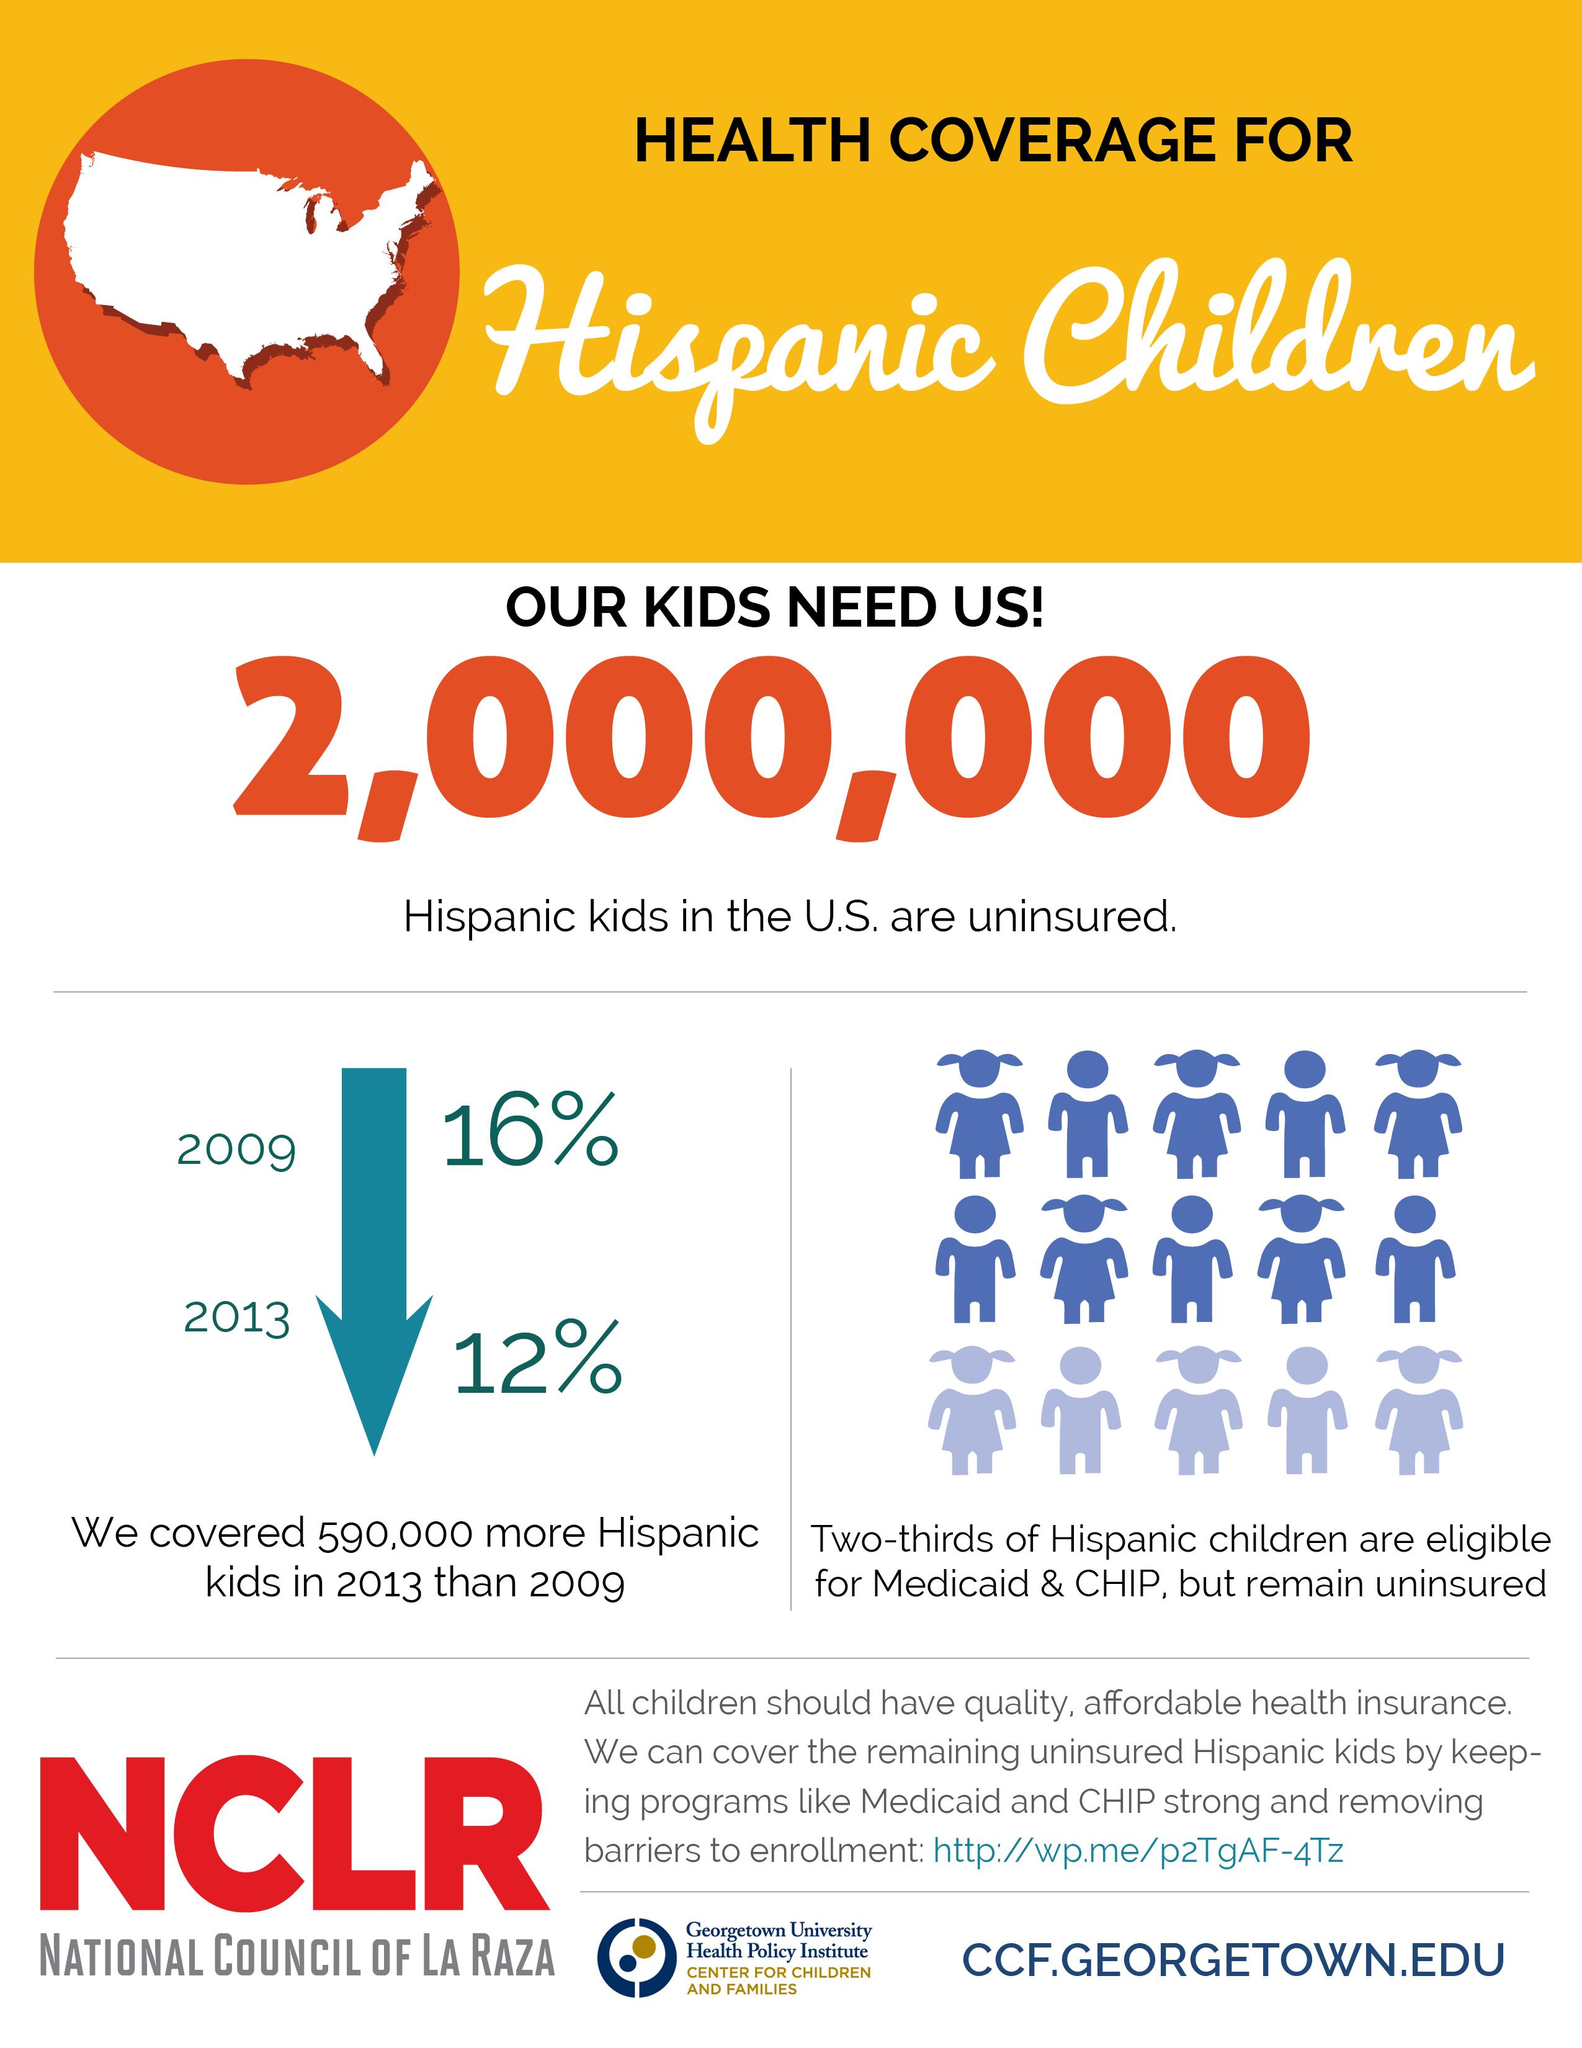Highlight a few significant elements in this photo. According to recent studies, approximately one-third of Hispanic children are insured, with a proportion of Hispanic children without insurance that remains a significant concern for the community. The number of uninsured children has decreased by 4% from 2009 to 2013. 